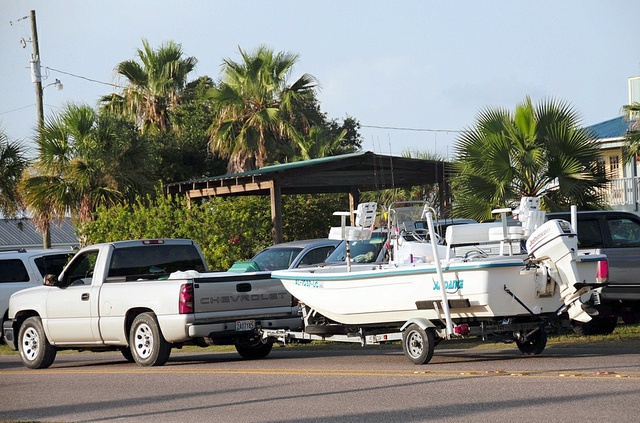Describe the objects in this image and their specific colors. I can see truck in lightgray, black, gray, and darkgray tones, boat in lightgray, white, darkgray, black, and gray tones, truck in lightgray, black, gray, and purple tones, car in lightgray, black, darkgray, and gray tones, and truck in lightgray, black, gray, and blue tones in this image. 